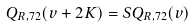Convert formula to latex. <formula><loc_0><loc_0><loc_500><loc_500>Q _ { R , 7 2 } ( v + 2 K ) = S Q _ { R , 7 2 } ( v )</formula> 